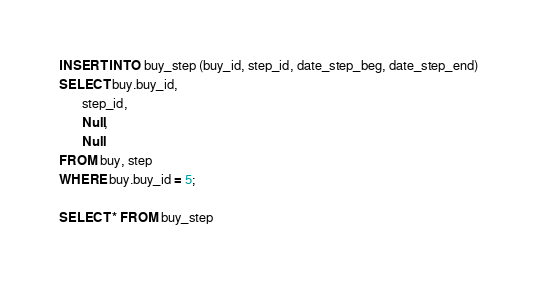<code> <loc_0><loc_0><loc_500><loc_500><_SQL_>INSERT INTO buy_step (buy_id, step_id, date_step_beg, date_step_end)
SELECT buy.buy_id, 
       step_id, 
       Null, 
       Null
FROM buy, step
WHERE buy.buy_id = 5;

SELECT * FROM buy_step
</code> 